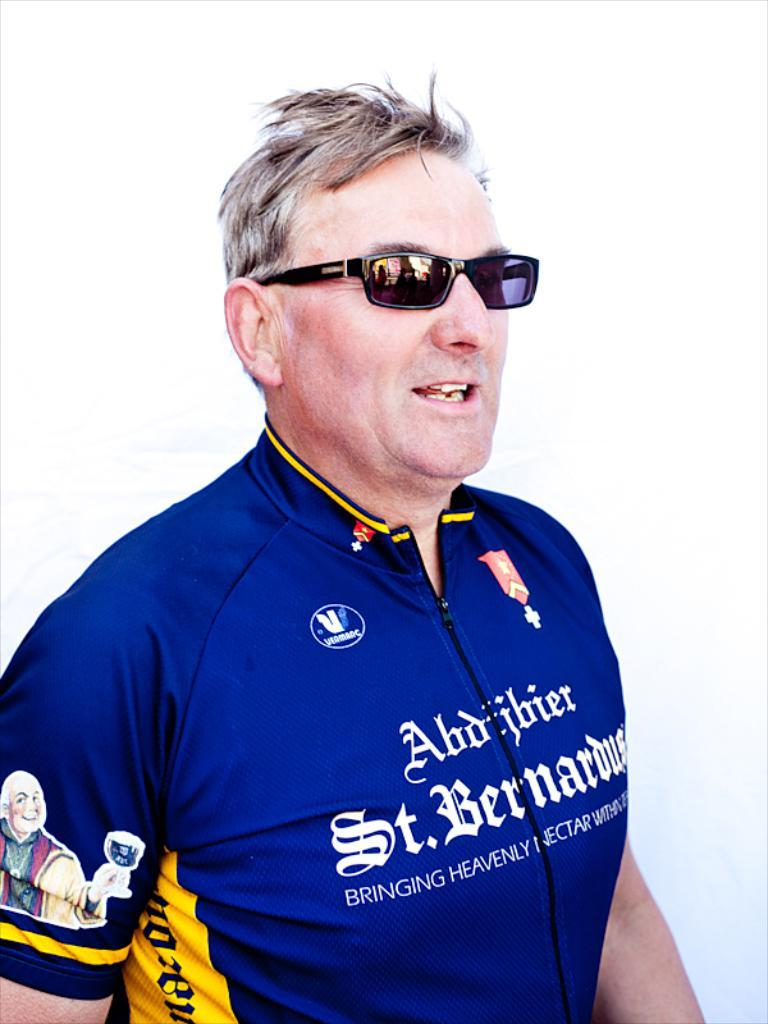<image>
Write a terse but informative summary of the picture. A man wearing a shirt with St. Bernardus across the front. 